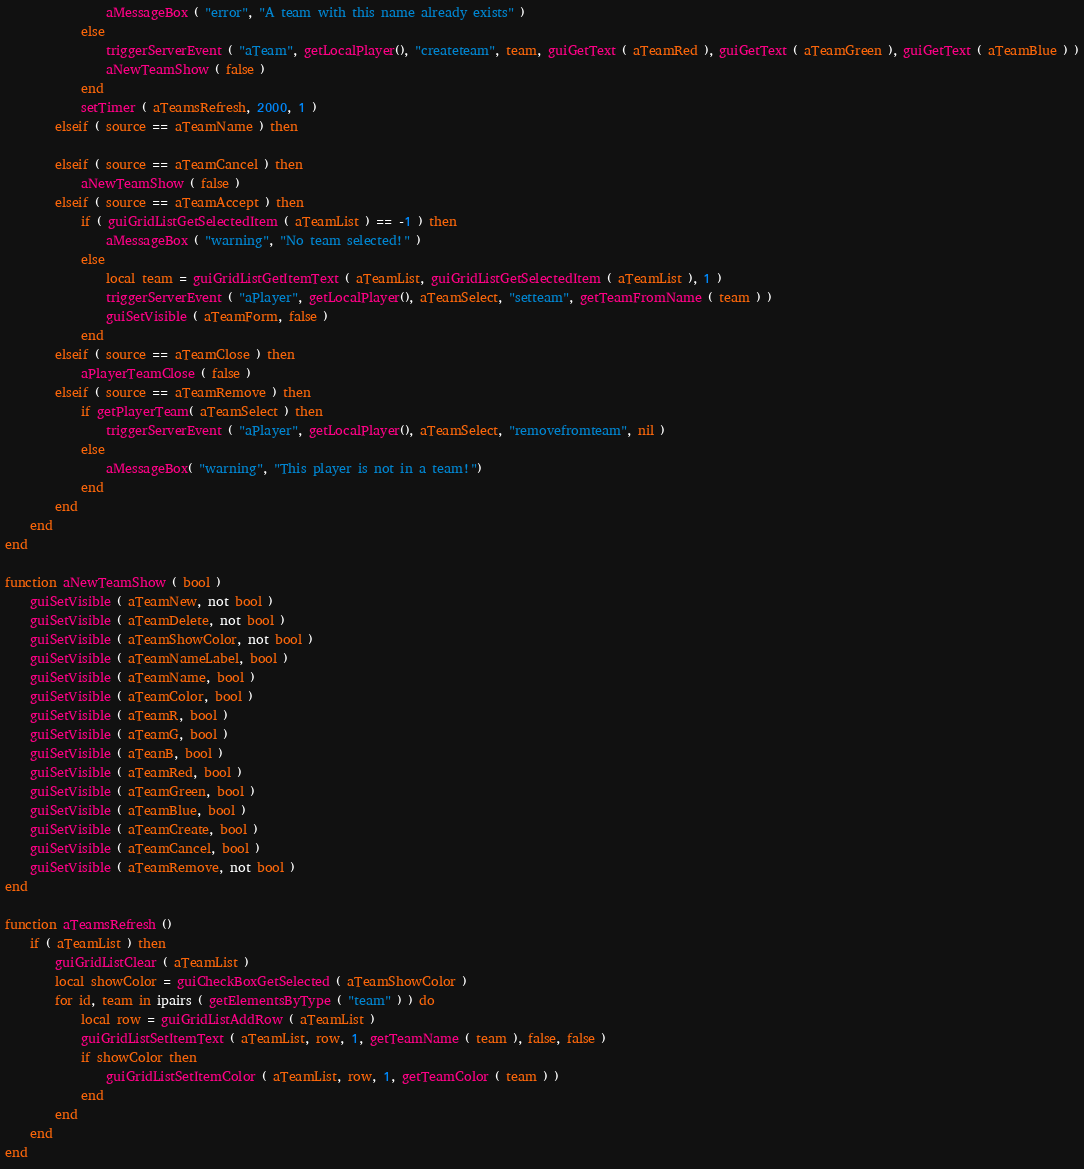<code> <loc_0><loc_0><loc_500><loc_500><_Lua_>				aMessageBox ( "error", "A team with this name already exists" )
			else
				triggerServerEvent ( "aTeam", getLocalPlayer(), "createteam", team, guiGetText ( aTeamRed ), guiGetText ( aTeamGreen ), guiGetText ( aTeamBlue ) )
				aNewTeamShow ( false )
			end
			setTimer ( aTeamsRefresh, 2000, 1 )
		elseif ( source == aTeamName ) then

		elseif ( source == aTeamCancel ) then
			aNewTeamShow ( false )
		elseif ( source == aTeamAccept ) then
			if ( guiGridListGetSelectedItem ( aTeamList ) == -1 ) then
				aMessageBox ( "warning", "No team selected!" )
			else
				local team = guiGridListGetItemText ( aTeamList, guiGridListGetSelectedItem ( aTeamList ), 1 )
				triggerServerEvent ( "aPlayer", getLocalPlayer(), aTeamSelect, "setteam", getTeamFromName ( team ) )
				guiSetVisible ( aTeamForm, false )
			end
		elseif ( source == aTeamClose ) then
			aPlayerTeamClose ( false )
		elseif ( source == aTeamRemove ) then
			if getPlayerTeam( aTeamSelect ) then
				triggerServerEvent ( "aPlayer", getLocalPlayer(), aTeamSelect, "removefromteam", nil )
			else
				aMessageBox( "warning", "This player is not in a team!")
			end
		end
	end
end

function aNewTeamShow ( bool )
	guiSetVisible ( aTeamNew, not bool )
	guiSetVisible ( aTeamDelete, not bool )
	guiSetVisible ( aTeamShowColor, not bool )
	guiSetVisible ( aTeamNameLabel, bool )
	guiSetVisible ( aTeamName, bool )
	guiSetVisible ( aTeamColor, bool )
	guiSetVisible ( aTeamR, bool )
	guiSetVisible ( aTeamG, bool )
	guiSetVisible ( aTeanB, bool )
	guiSetVisible ( aTeamRed, bool )
	guiSetVisible ( aTeamGreen, bool )
	guiSetVisible ( aTeamBlue, bool )
	guiSetVisible ( aTeamCreate, bool )
	guiSetVisible ( aTeamCancel, bool )
	guiSetVisible ( aTeamRemove, not bool )
end

function aTeamsRefresh ()
	if ( aTeamList ) then
		guiGridListClear ( aTeamList )
		local showColor = guiCheckBoxGetSelected ( aTeamShowColor )
		for id, team in ipairs ( getElementsByType ( "team" ) ) do
			local row = guiGridListAddRow ( aTeamList )
			guiGridListSetItemText ( aTeamList, row, 1, getTeamName ( team ), false, false )
			if showColor then
				guiGridListSetItemColor ( aTeamList, row, 1, getTeamColor ( team ) )
			end
		end
	end
end
</code> 